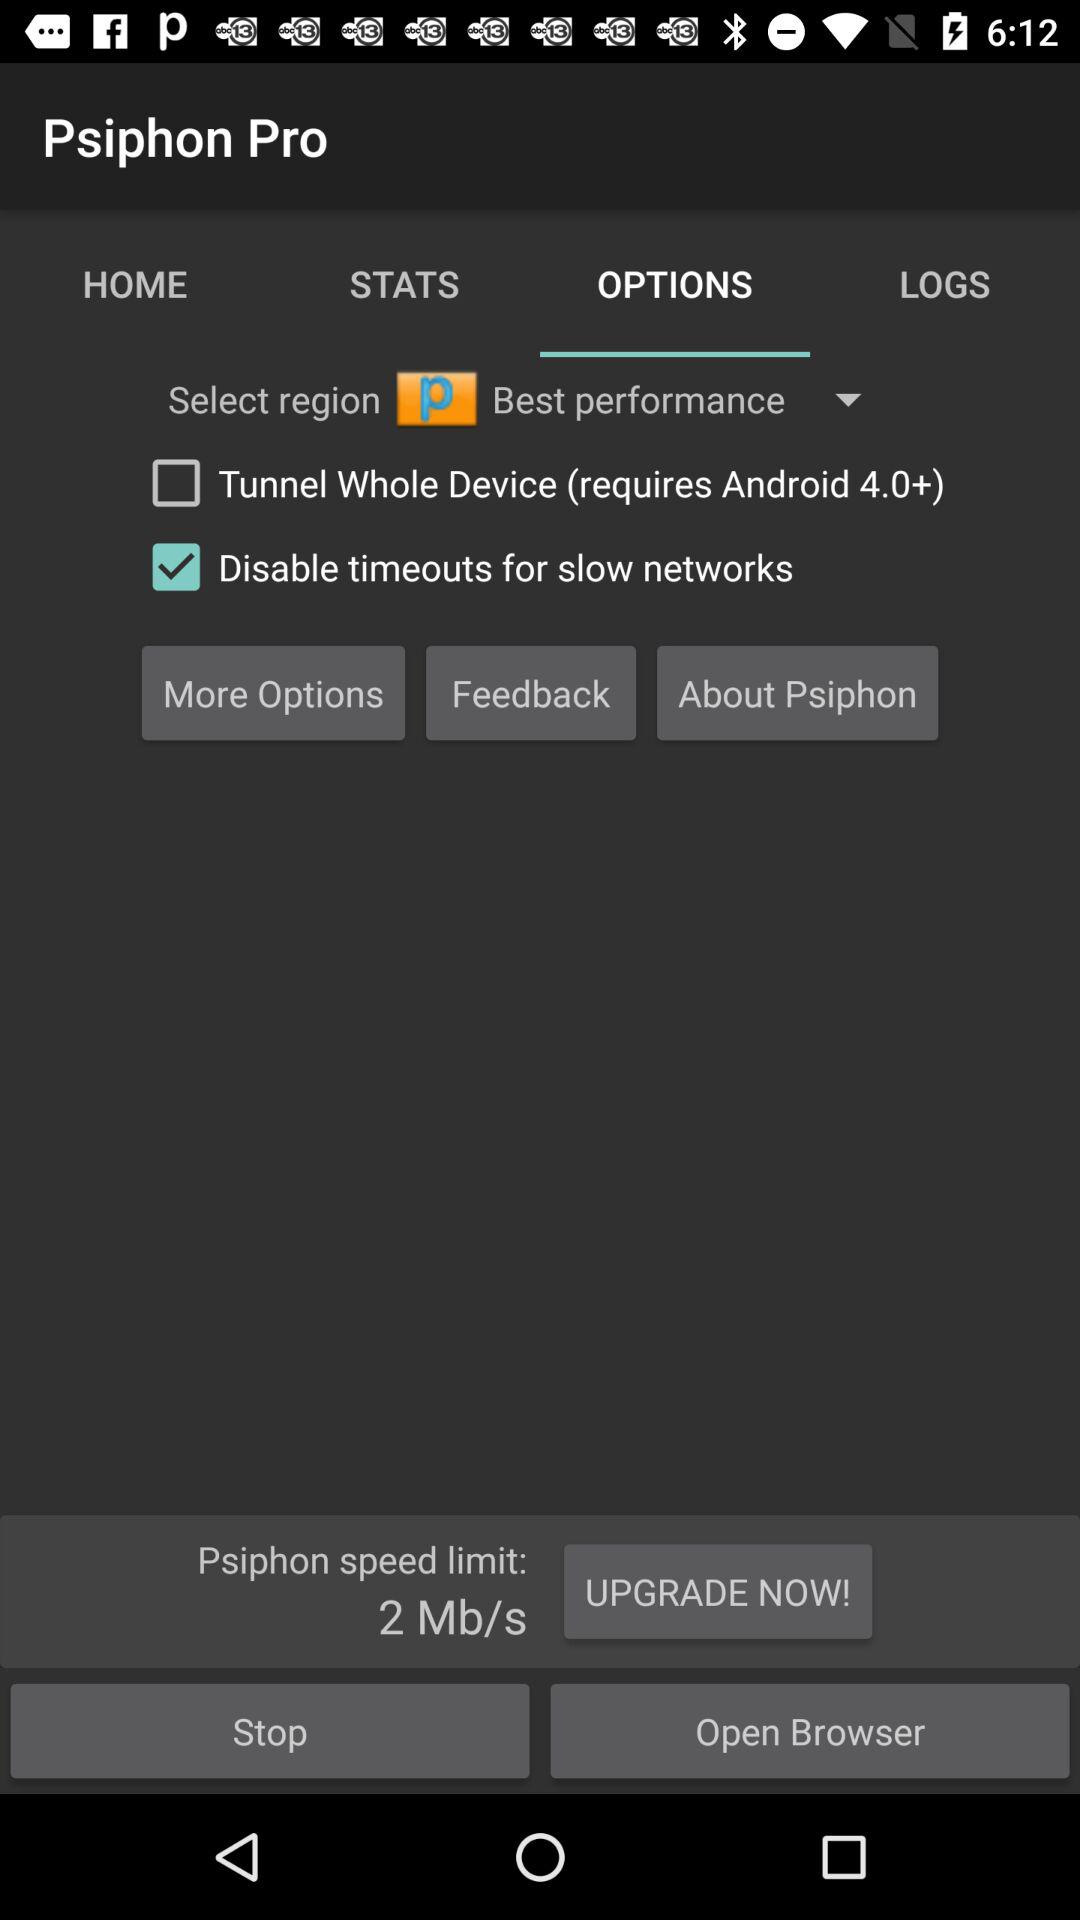What is the selected tab? The selected tab is "OPTIONS". 